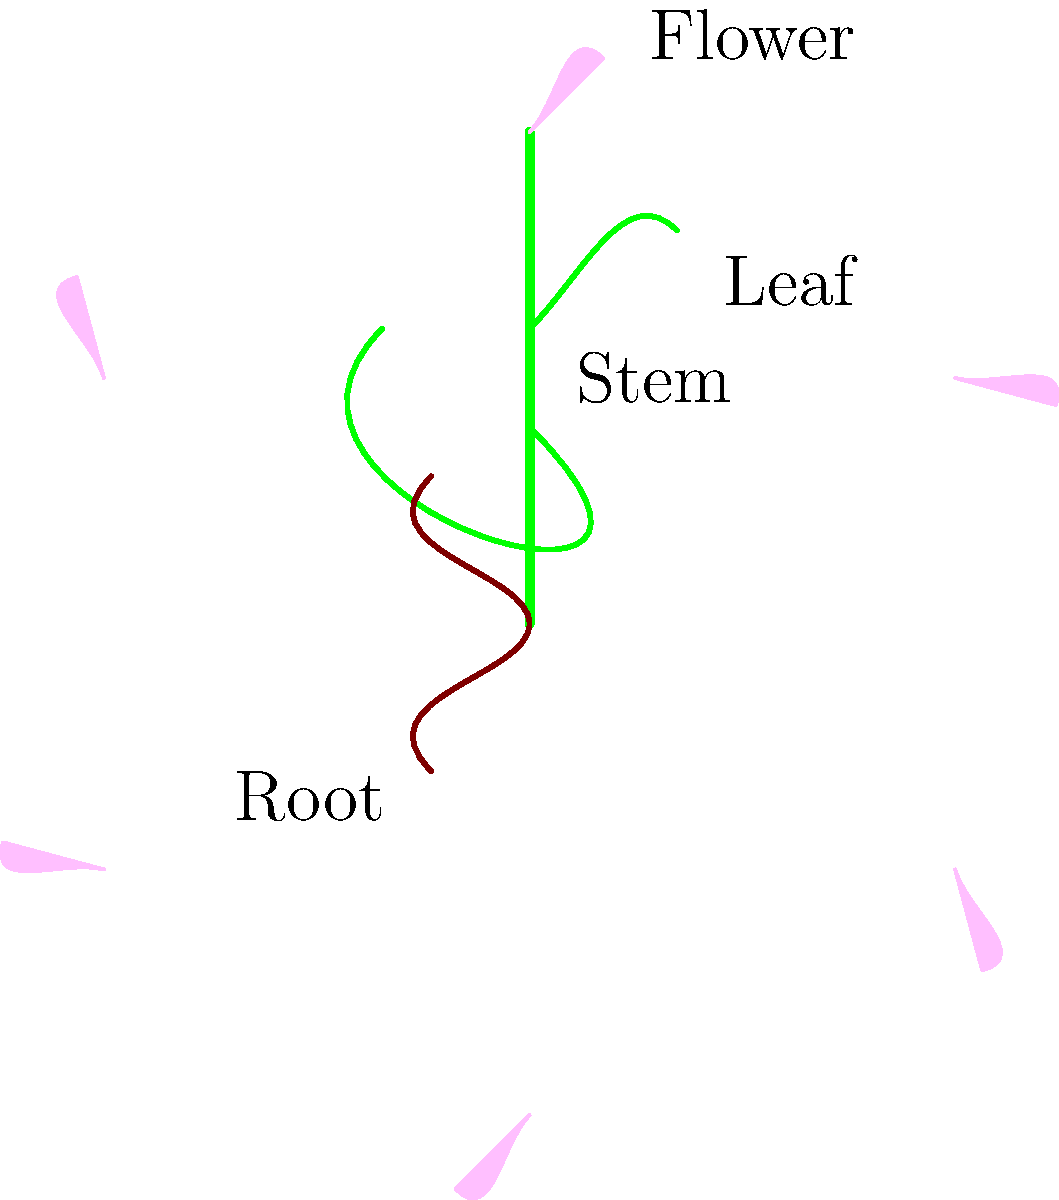Which part of this medicinal plant is most commonly used for its anti-inflammatory properties in traditional herbal remedies? To answer this question, let's consider the different parts of the plant and their typical uses in herbal medicine:

1. Flower: Often used for aromatic and soothing properties, sometimes in teas or essential oils.
2. Leaf: Frequently used in herbal remedies, especially for their phytochemical content.
3. Stem: Less commonly used, but can contain some active compounds.
4. Root: Often contains potent medicinal compounds, including those with anti-inflammatory properties.

In many medicinal plants, the root is the part that contains the highest concentration of anti-inflammatory compounds. For example:

- Turmeric root contains curcumin, a powerful anti-inflammatory compound.
- Ginger root is widely used for its anti-inflammatory and pain-relieving properties.
- Licorice root contains glycyrrhizin, which has anti-inflammatory effects.

While other parts of plants can also have anti-inflammatory properties, the root is often the most potent source of these compounds. This is because roots serve as storage organs for many plants, accumulating beneficial compounds over time.

Therefore, in traditional herbal remedies, the root is most commonly used for its anti-inflammatory properties.
Answer: Root 